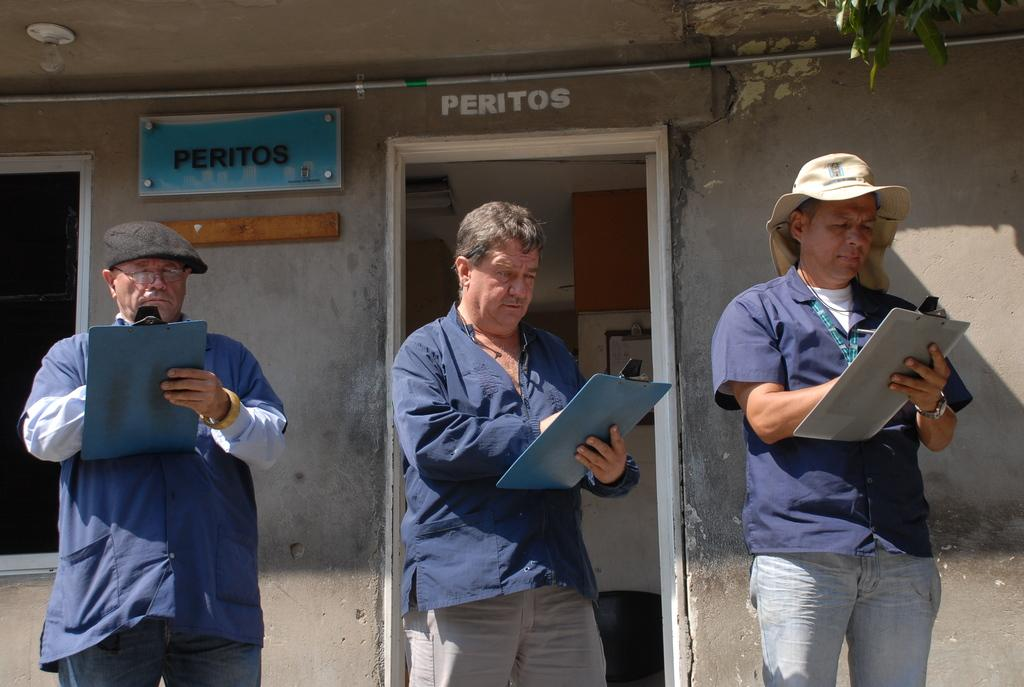How many people are in the image? There are three men in the image. What are the men wearing? The men are wearing blue shirts. What are the men holding in their hands? The men are holding pads in their hands. What are the men doing with the pads? The men are writing something on the pads. What can be seen in the background of the image? There is a grey color wall with a door in the background. Can you see the fang of the snake in the image? There is no snake or fang present in the image. What does the aunt of the men in the image look like? There is no mention of an aunt in the image or the provided facts. 